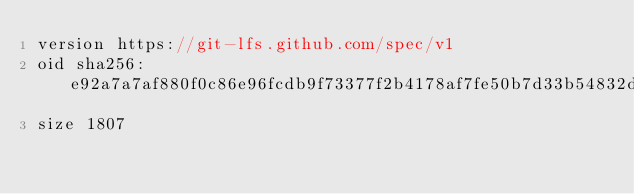Convert code to text. <code><loc_0><loc_0><loc_500><loc_500><_JavaScript_>version https://git-lfs.github.com/spec/v1
oid sha256:e92a7a7af880f0c86e96fcdb9f73377f2b4178af7fe50b7d33b54832d80f71e4
size 1807
</code> 